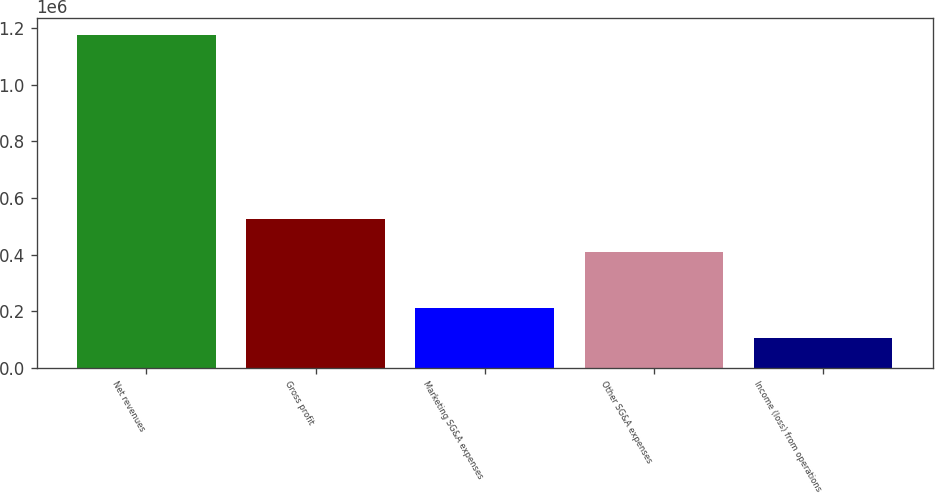Convert chart to OTSL. <chart><loc_0><loc_0><loc_500><loc_500><bar_chart><fcel>Net revenues<fcel>Gross profit<fcel>Marketing SG&A expenses<fcel>Other SG&A expenses<fcel>Income (loss) from operations<nl><fcel>1.17486e+06<fcel>526584<fcel>211873<fcel>411147<fcel>104875<nl></chart> 